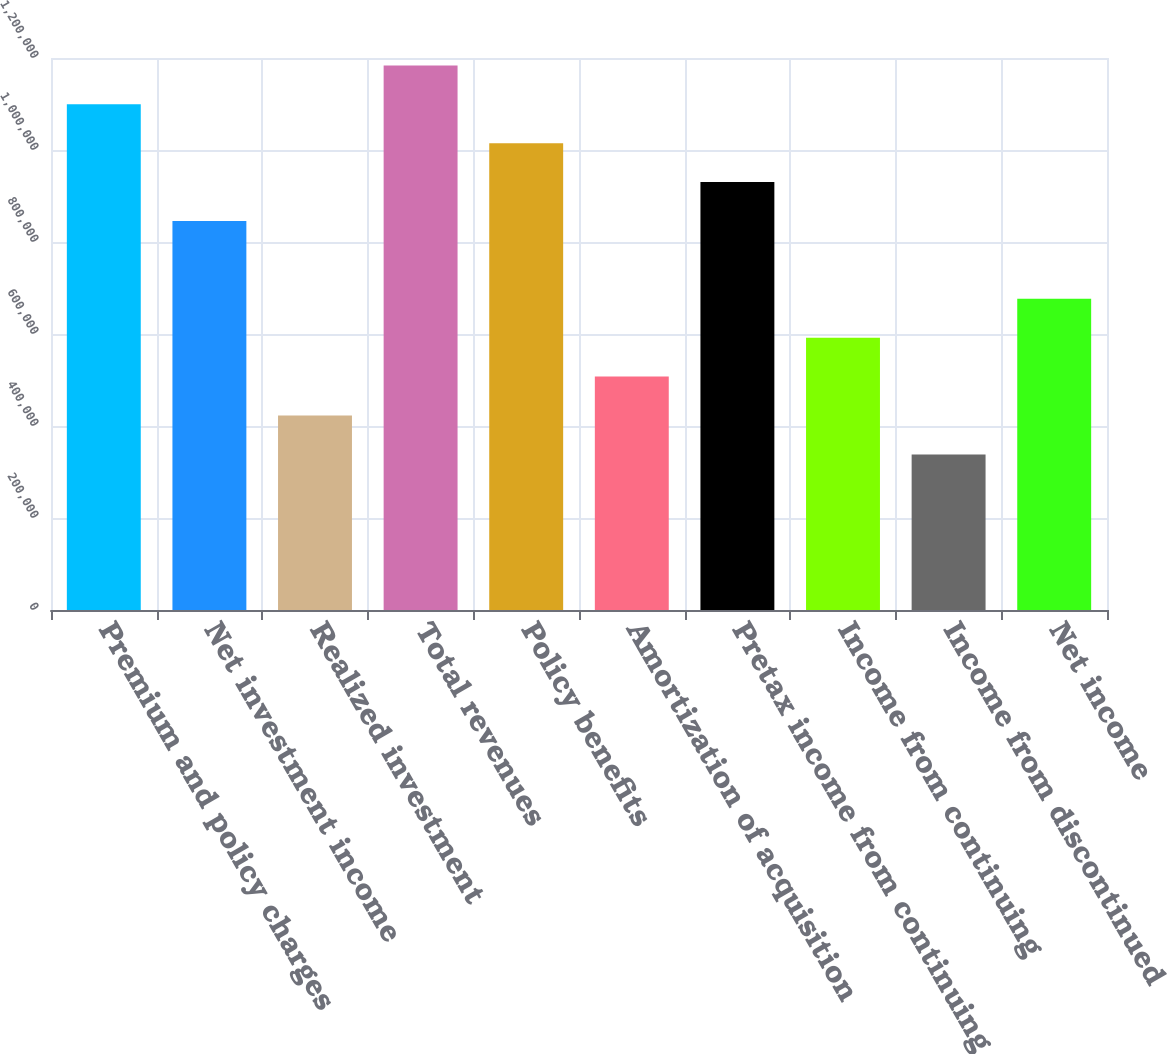Convert chart to OTSL. <chart><loc_0><loc_0><loc_500><loc_500><bar_chart><fcel>Premium and policy charges<fcel>Net investment income<fcel>Realized investment<fcel>Total revenues<fcel>Policy benefits<fcel>Amortization of acquisition<fcel>Pretax income from continuing<fcel>Income from continuing<fcel>Income from discontinued<fcel>Net income<nl><fcel>1.09938e+06<fcel>845678<fcel>422839<fcel>1.18395e+06<fcel>1.01481e+06<fcel>507407<fcel>930246<fcel>591975<fcel>338271<fcel>676542<nl></chart> 